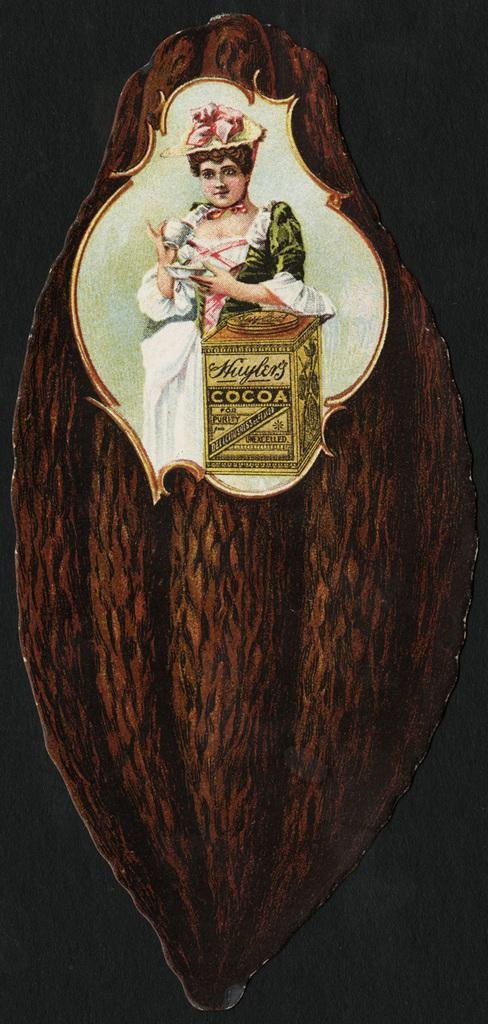What is the main subject of the image? There is a picture of a lady in the image. What is the lady holding in the image? The lady is holding a cup and a saucer. Can you describe any other objects in the image? There is a box on the wood in the image. What type of cord is being played in harmony by the lady in the image? There is no cord or musical instrument present in the image, and the lady is not playing anything in harmony. 